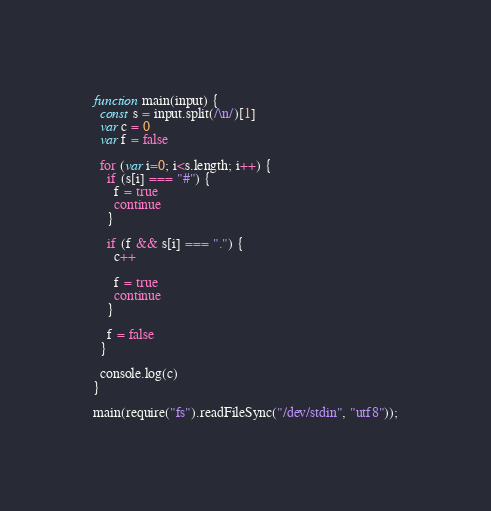<code> <loc_0><loc_0><loc_500><loc_500><_JavaScript_>function main(input) {
  const s = input.split(/\n/)[1]  
  var c = 0
  var f = false
  
  for (var i=0; i<s.length; i++) {
    if (s[i] === "#") {
      f = true
      continue
    }
    
    if (f && s[i] === ".") {
      c++
      
      f = true
      continue
    }
    
    f = false
  }
  
  console.log(c)
}

main(require("fs").readFileSync("/dev/stdin", "utf8"));</code> 